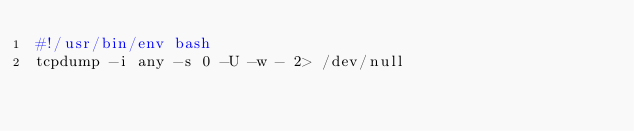<code> <loc_0><loc_0><loc_500><loc_500><_Bash_>#!/usr/bin/env bash
tcpdump -i any -s 0 -U -w - 2> /dev/null</code> 